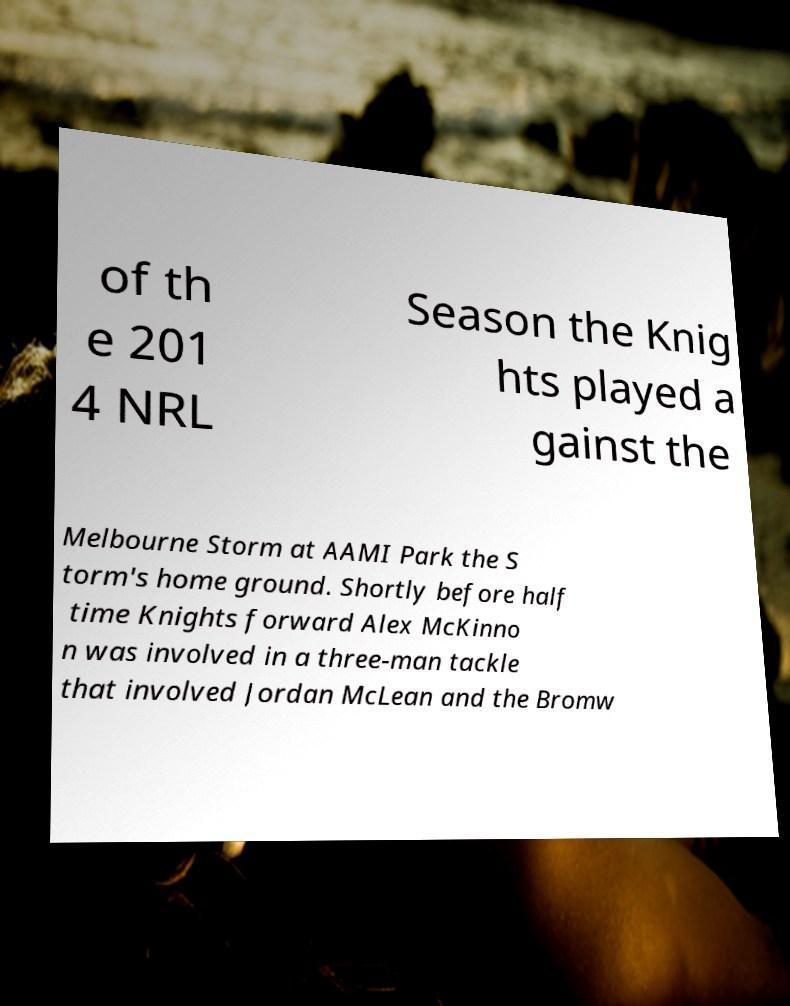There's text embedded in this image that I need extracted. Can you transcribe it verbatim? of th e 201 4 NRL Season the Knig hts played a gainst the Melbourne Storm at AAMI Park the S torm's home ground. Shortly before half time Knights forward Alex McKinno n was involved in a three-man tackle that involved Jordan McLean and the Bromw 